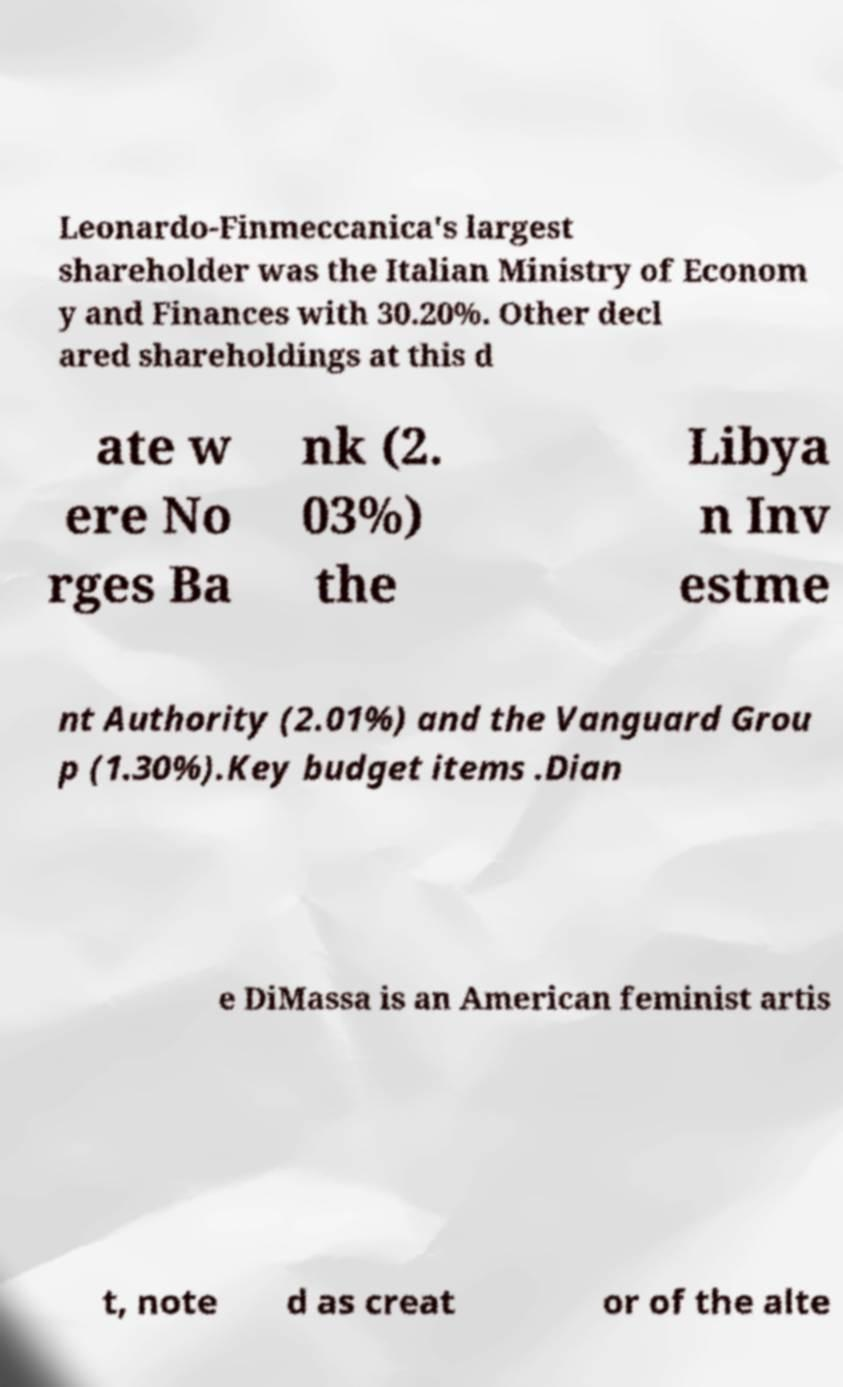Please identify and transcribe the text found in this image. Leonardo-Finmeccanica's largest shareholder was the Italian Ministry of Econom y and Finances with 30.20%. Other decl ared shareholdings at this d ate w ere No rges Ba nk (2. 03%) the Libya n Inv estme nt Authority (2.01%) and the Vanguard Grou p (1.30%).Key budget items .Dian e DiMassa is an American feminist artis t, note d as creat or of the alte 